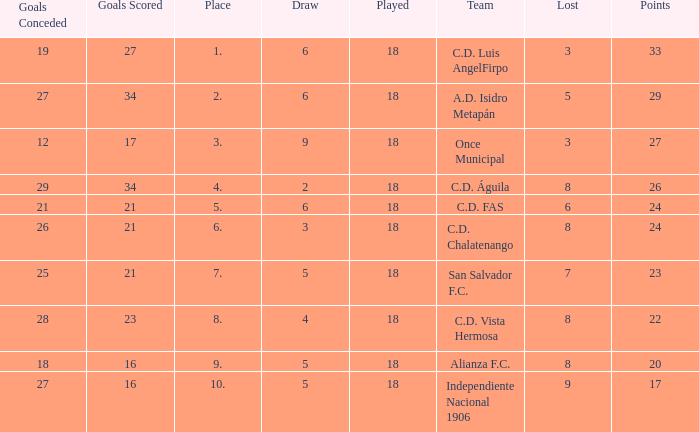What are the number of goals conceded that has a played greater than 18? 0.0. 